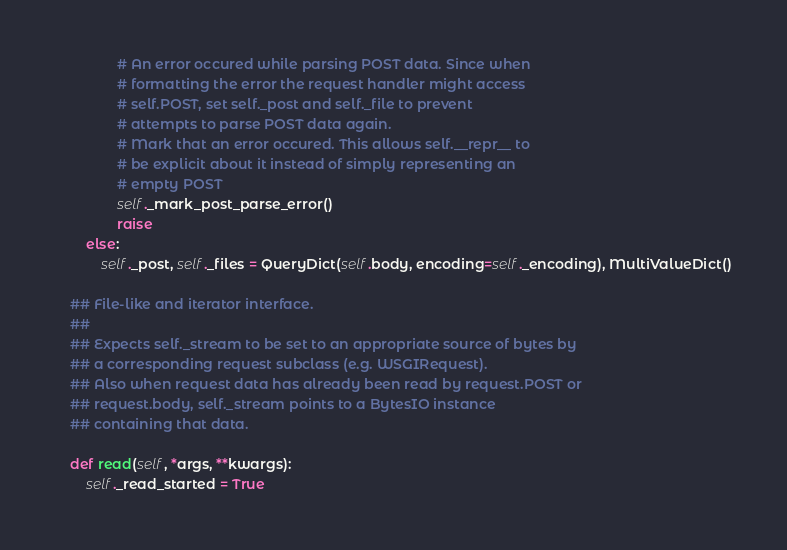Convert code to text. <code><loc_0><loc_0><loc_500><loc_500><_Python_>                # An error occured while parsing POST data. Since when
                # formatting the error the request handler might access
                # self.POST, set self._post and self._file to prevent
                # attempts to parse POST data again.
                # Mark that an error occured. This allows self.__repr__ to
                # be explicit about it instead of simply representing an
                # empty POST
                self._mark_post_parse_error()
                raise
        else:
            self._post, self._files = QueryDict(self.body, encoding=self._encoding), MultiValueDict()

    ## File-like and iterator interface.
    ##
    ## Expects self._stream to be set to an appropriate source of bytes by
    ## a corresponding request subclass (e.g. WSGIRequest).
    ## Also when request data has already been read by request.POST or
    ## request.body, self._stream points to a BytesIO instance
    ## containing that data.

    def read(self, *args, **kwargs):
        self._read_started = True</code> 